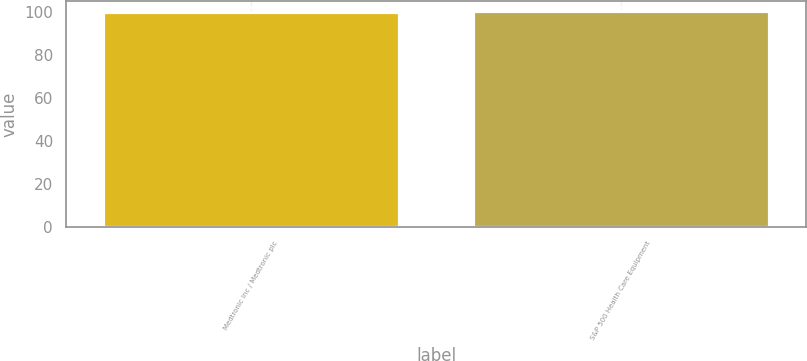<chart> <loc_0><loc_0><loc_500><loc_500><bar_chart><fcel>Medtronic Inc / Medtronic plc<fcel>S&P 500 Health Care Equipment<nl><fcel>100<fcel>100.1<nl></chart> 